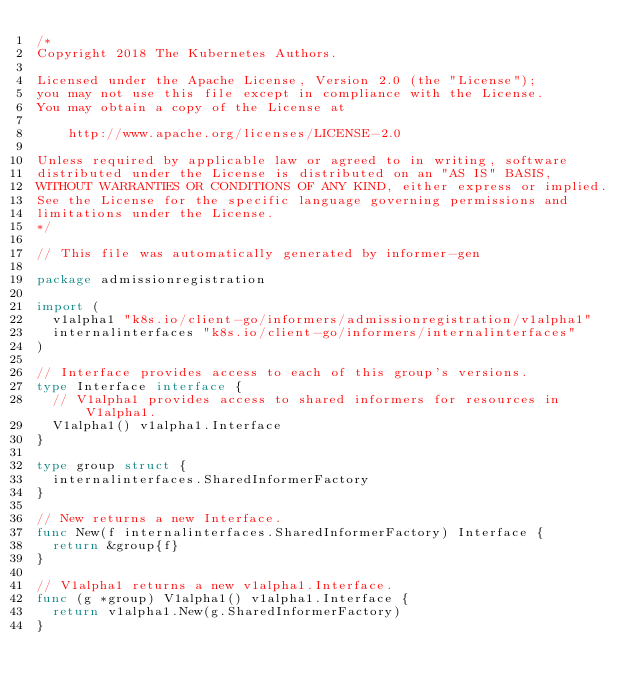<code> <loc_0><loc_0><loc_500><loc_500><_Go_>/*
Copyright 2018 The Kubernetes Authors.

Licensed under the Apache License, Version 2.0 (the "License");
you may not use this file except in compliance with the License.
You may obtain a copy of the License at

    http://www.apache.org/licenses/LICENSE-2.0

Unless required by applicable law or agreed to in writing, software
distributed under the License is distributed on an "AS IS" BASIS,
WITHOUT WARRANTIES OR CONDITIONS OF ANY KIND, either express or implied.
See the License for the specific language governing permissions and
limitations under the License.
*/

// This file was automatically generated by informer-gen

package admissionregistration

import (
	v1alpha1 "k8s.io/client-go/informers/admissionregistration/v1alpha1"
	internalinterfaces "k8s.io/client-go/informers/internalinterfaces"
)

// Interface provides access to each of this group's versions.
type Interface interface {
	// V1alpha1 provides access to shared informers for resources in V1alpha1.
	V1alpha1() v1alpha1.Interface
}

type group struct {
	internalinterfaces.SharedInformerFactory
}

// New returns a new Interface.
func New(f internalinterfaces.SharedInformerFactory) Interface {
	return &group{f}
}

// V1alpha1 returns a new v1alpha1.Interface.
func (g *group) V1alpha1() v1alpha1.Interface {
	return v1alpha1.New(g.SharedInformerFactory)
}
</code> 